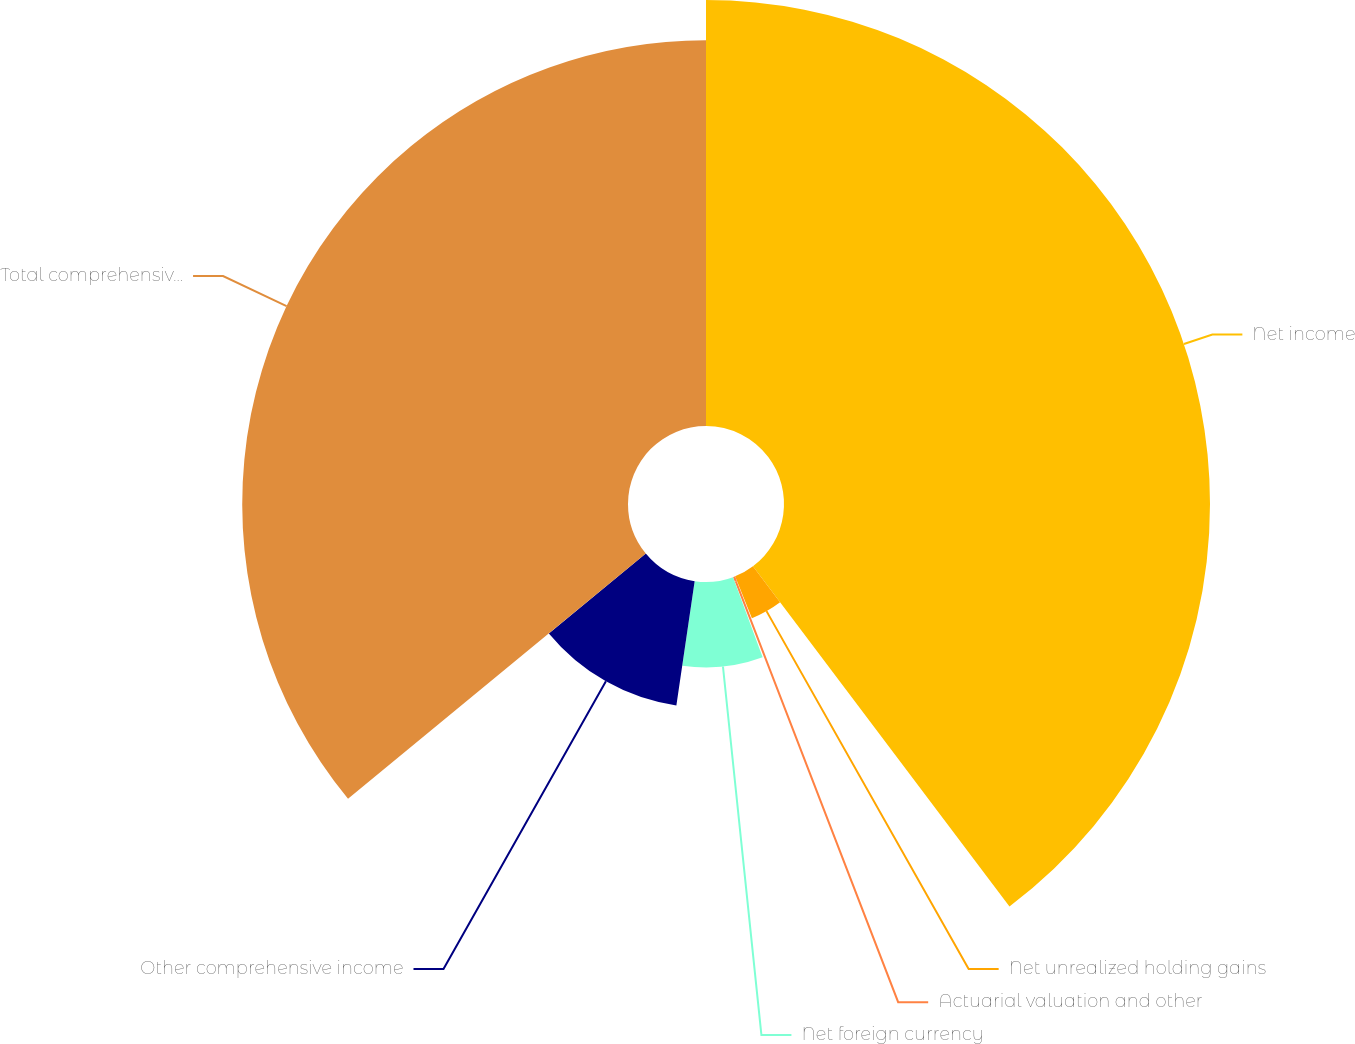Convert chart to OTSL. <chart><loc_0><loc_0><loc_500><loc_500><pie_chart><fcel>Net income<fcel>Net unrealized holding gains<fcel>Actuarial valuation and other<fcel>Net foreign currency<fcel>Other comprehensive income<fcel>Total comprehensive income<nl><fcel>39.72%<fcel>4.2%<fcel>0.45%<fcel>7.96%<fcel>11.71%<fcel>35.97%<nl></chart> 